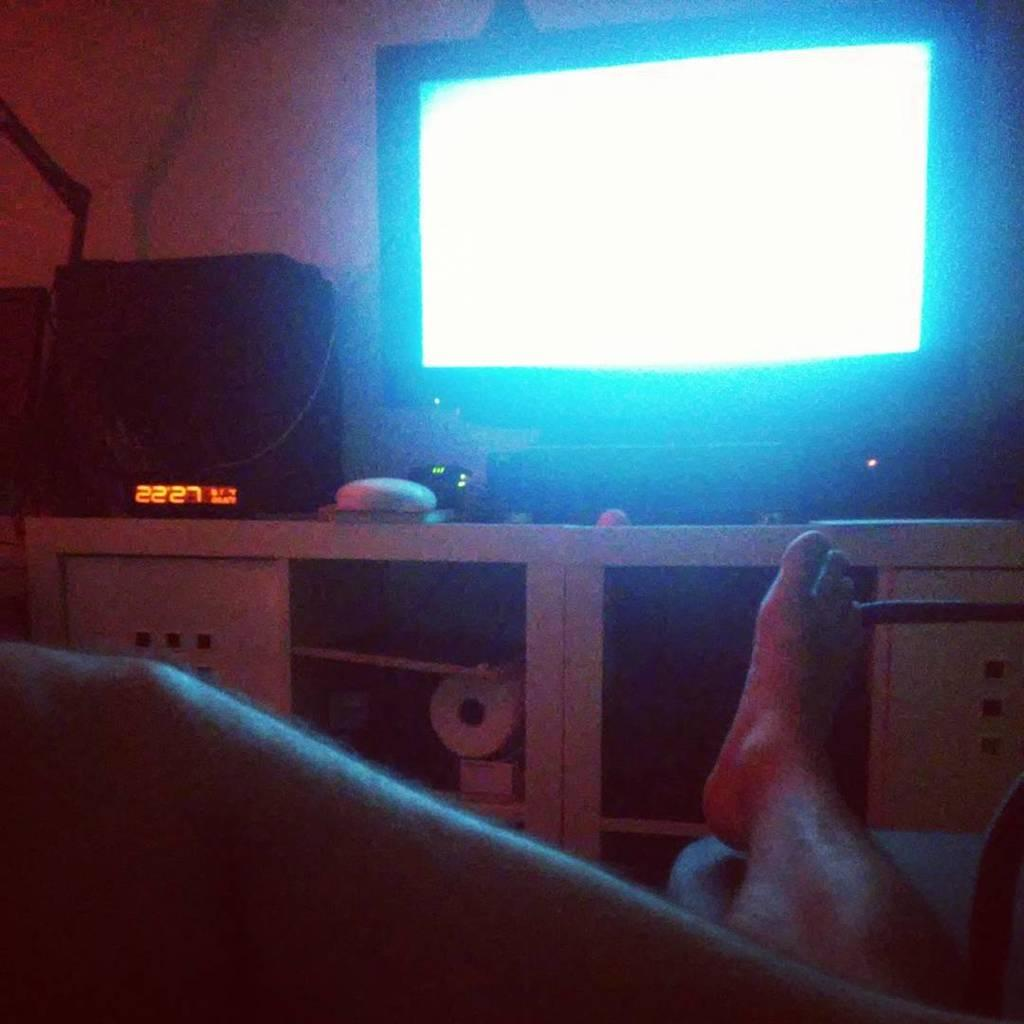Provide a one-sentence caption for the provided image. An orange digital display has the numbers 2227 on it. 